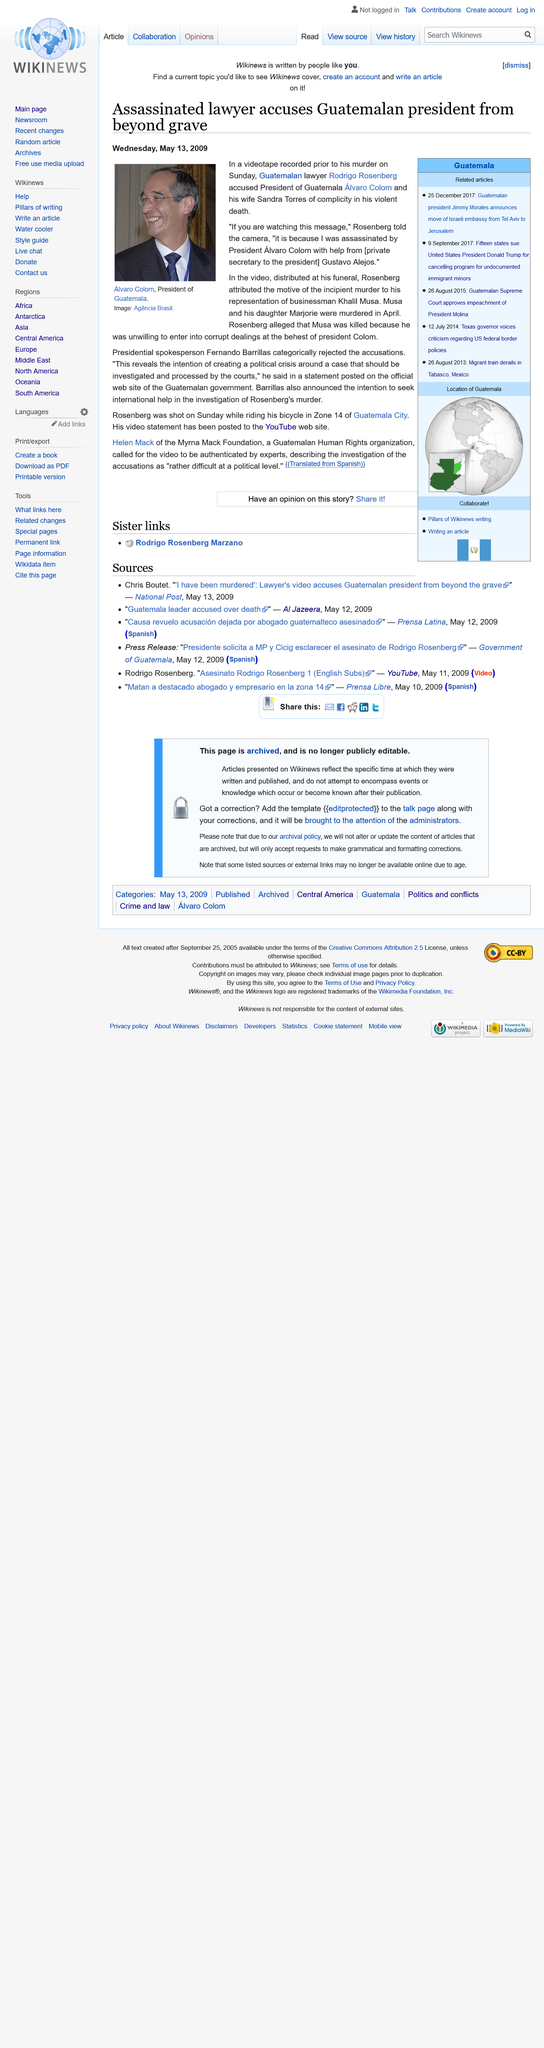Mention a couple of crucial points in this snapshot. Khalil Musa and his daughter, Marjorie, were both murdered. Rosenberg alleged that Musa was killed because Musa refused to engage in corrupt activities. Alvaro Colom is married to Sandra Torres. 